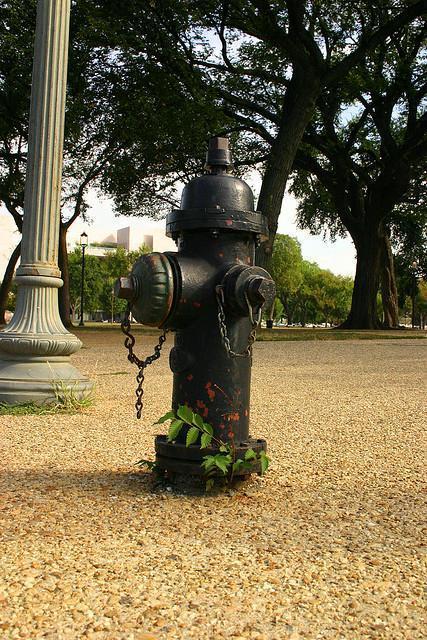How many people are wearing a green hat?
Give a very brief answer. 0. 